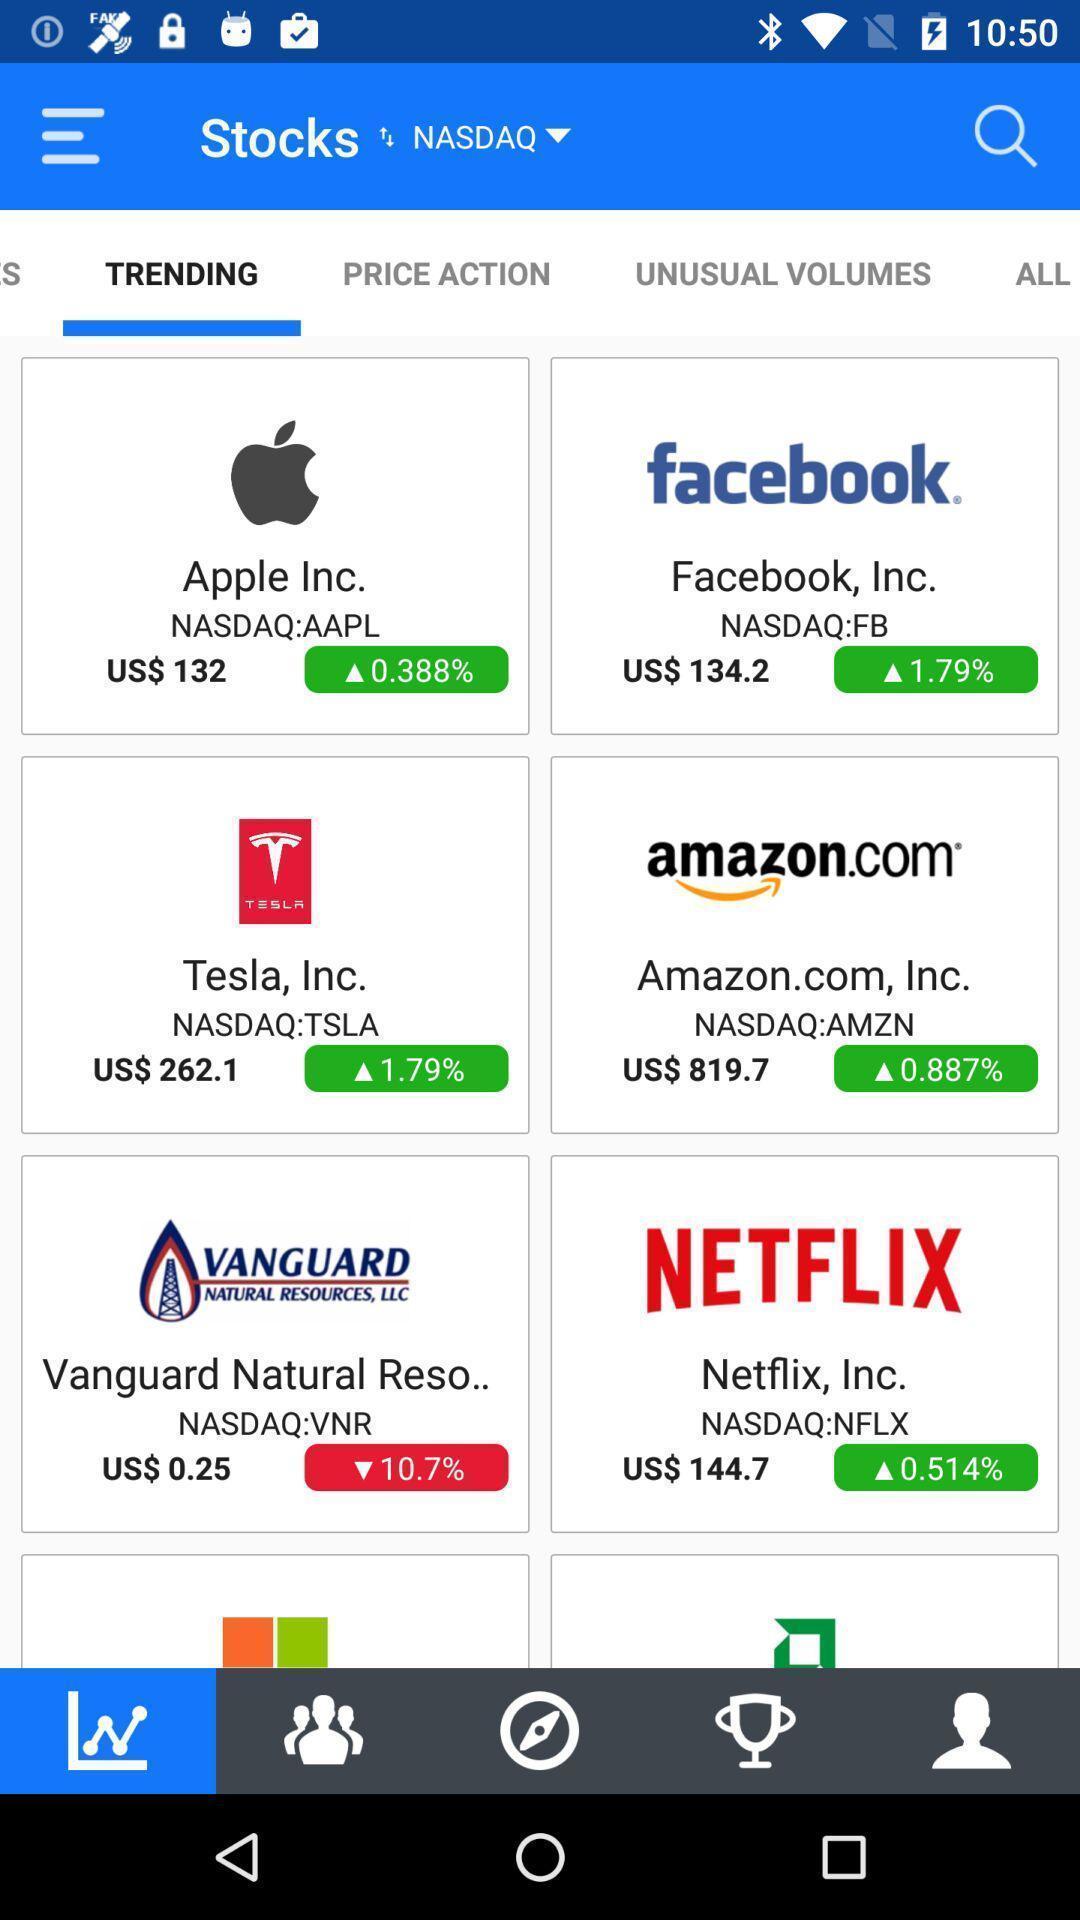Explain what's happening in this screen capture. Various trending stocks in the application. 